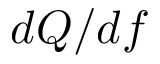Convert formula to latex. <formula><loc_0><loc_0><loc_500><loc_500>d Q / d f</formula> 